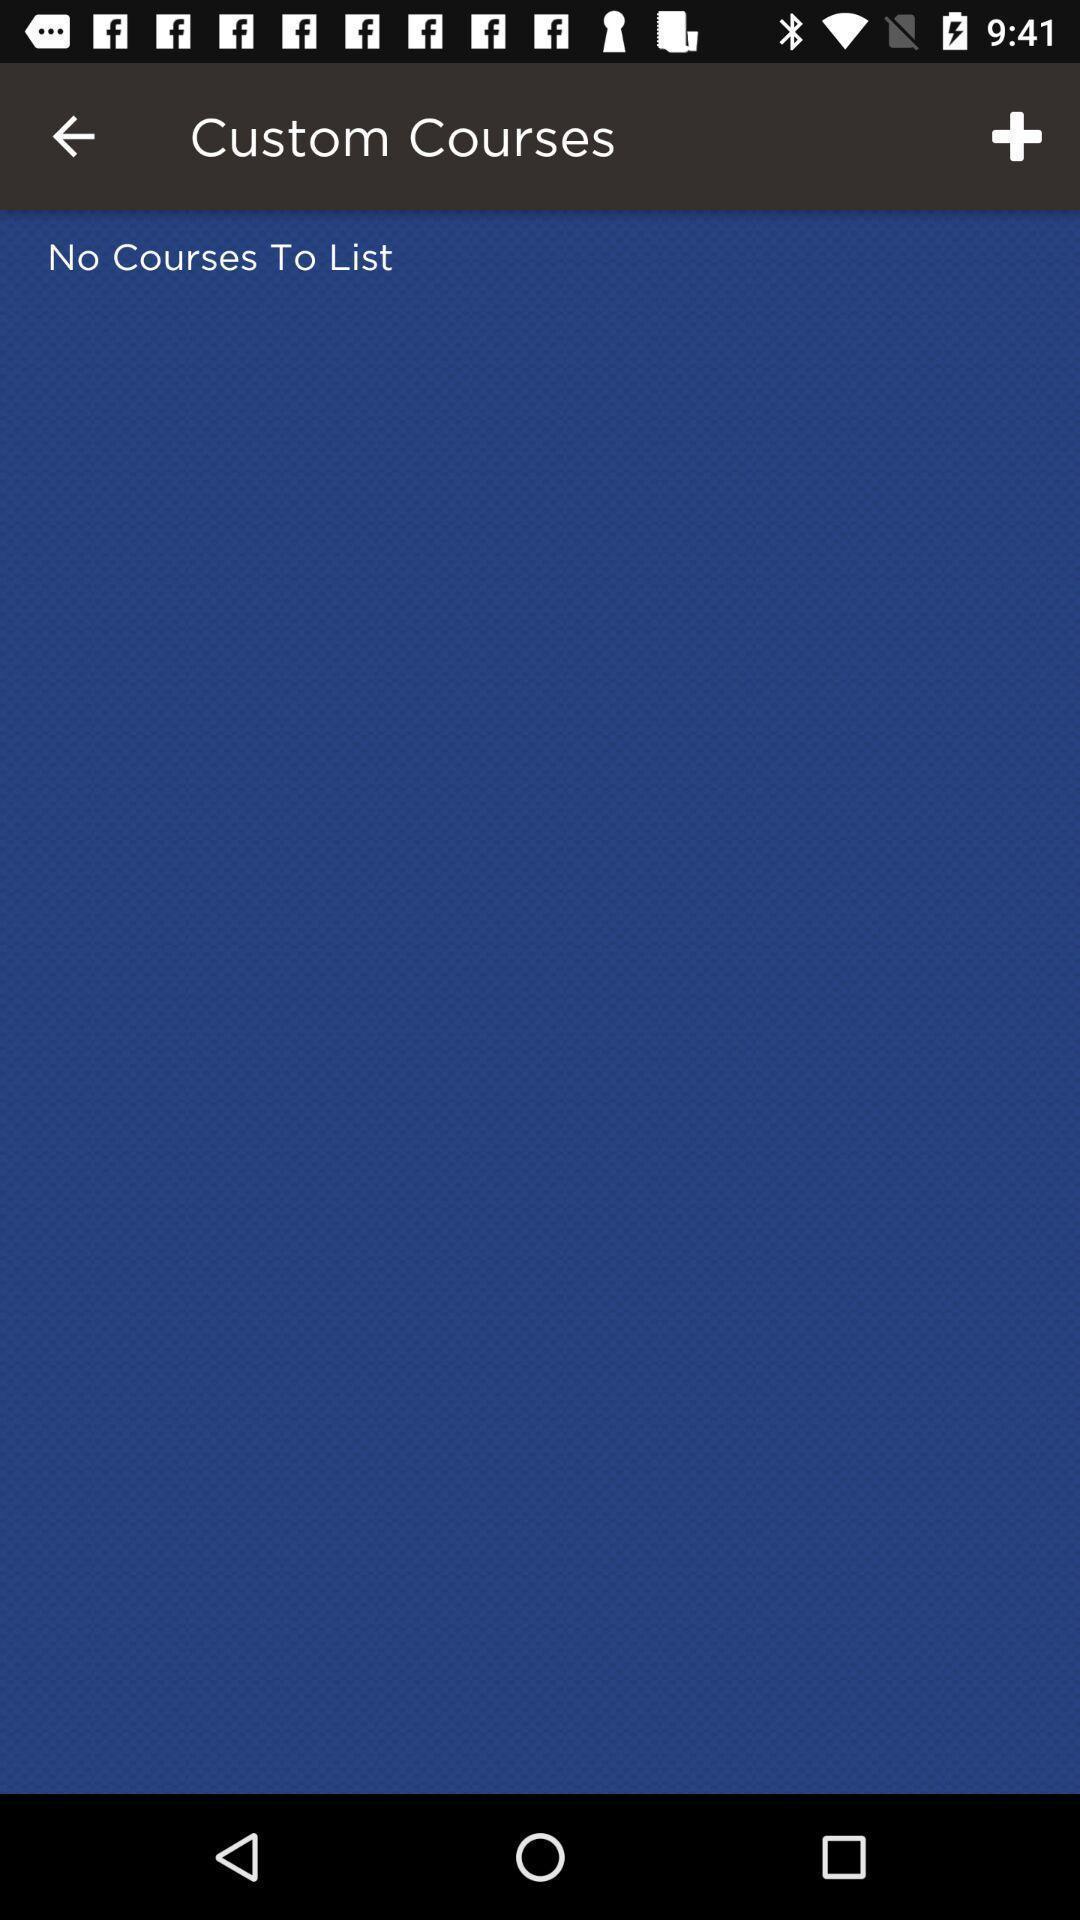Describe the visual elements of this screenshot. Screen shows custom courses. 